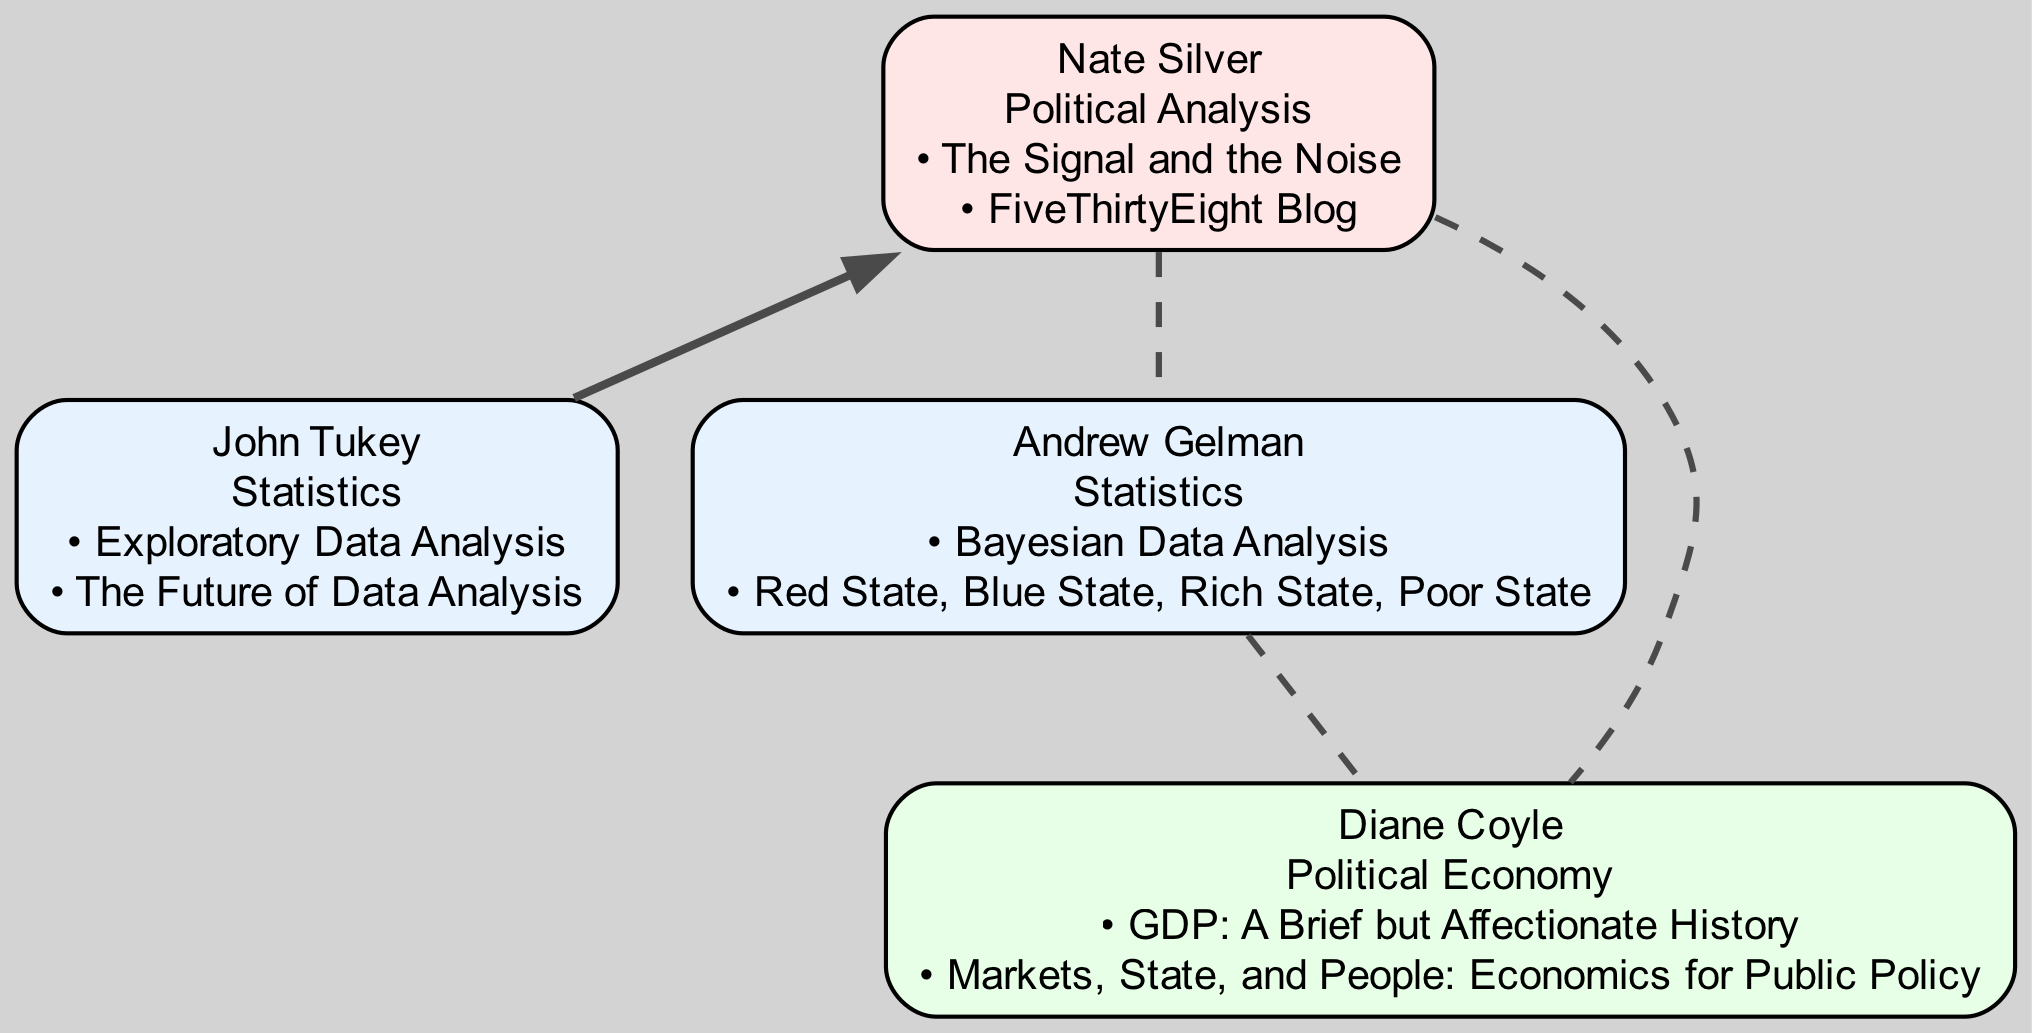What is the field of John Tukey? The diagram indicates that John Tukey's field is labeled as "Statistics."
Answer: Statistics How many key publications does Nate Silver have? A review of the diagram shows two key publications listed under Nate Silver: "The Signal and the Noise" and "FiveThirtyEight Blog." This totals to two publications.
Answer: 2 Who mentored Nate Silver? According to the diagram, it explicitly states that Nate Silver was mentored by John Tukey.
Answer: John Tukey What relationship exists between Andrew Gelman and Diane Coyle? The diagram shows that both Andrew Gelman and Diane Coyle are connected as collaborators, indicated by a dashed line between them.
Answer: collaborator Which publication is attributed to Andrew Gelman? The diagram lists two key publications of Andrew Gelman, including "Bayesian Data Analysis," which is one of them.
Answer: Bayesian Data Analysis How many nodes are in the diagram? By counting the nodes presented in the diagram, we find a total of four nodes: John Tukey, Nate Silver, Andrew Gelman, and Diane Coyle.
Answer: 4 Which node is connected to two collaborators? The diagram shows that Nate Silver is connected to two collaborators, Andrew Gelman and Diane Coyle, as indicated by dashed lines.
Answer: Nate Silver What field does Diane Coyle specialize in? The diagram indicates that Diane Coyle's field is labeled as "Political Economy."
Answer: Political Economy What is the first key publication listed for John Tukey? Based on the layout of the diagram, the first key publication listed under John Tukey is "Exploratory Data Analysis."
Answer: Exploratory Data Analysis 